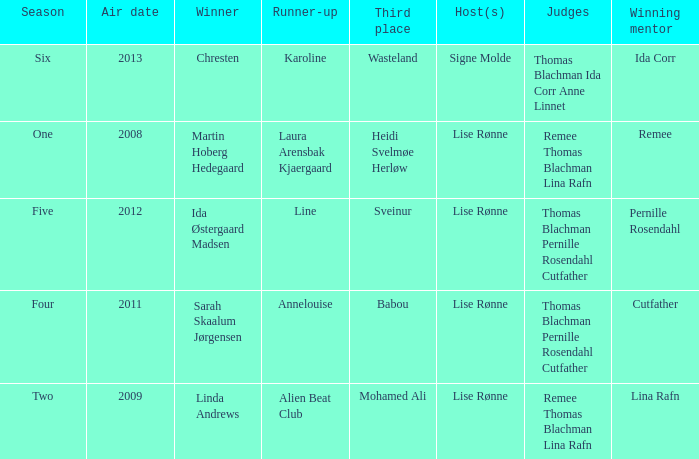Who was the runner-up when Mohamed Ali got third? Alien Beat Club. 